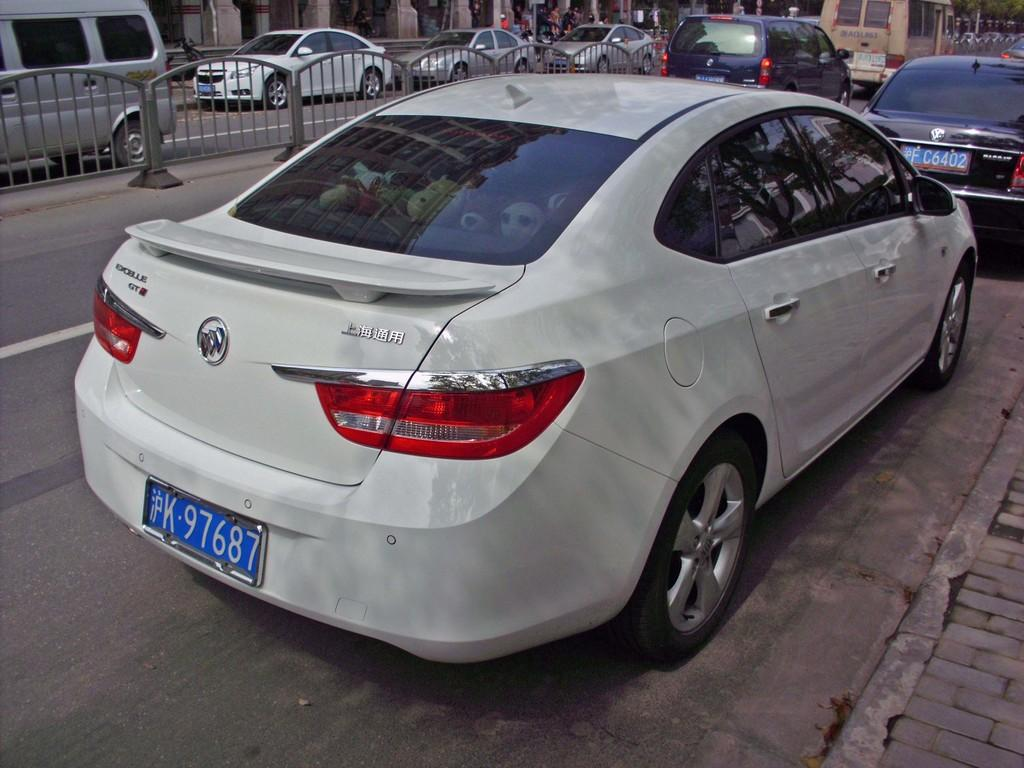What is happening on the road in the image? There are vehicles on the road in the image. What separates the roads in the image? There are barriers between the roads in the image. Who or what can be seen behind the vehicles in the image? People are visible behind the vehicles in the image. What structures are present behind the vehicles in the image? Pillars are present behind the vehicles in the image. What type of vegetation is visible behind the vehicles in the image? Trees are visible behind the vehicles in the image. What type of bait is being used to catch fish in the image? There is no fishing or bait present in the image; it features vehicles on the road with barriers, people, pillars, and trees in the background. 